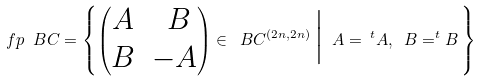Convert formula to latex. <formula><loc_0><loc_0><loc_500><loc_500>\ f p _ { \ } B C = \left \{ \begin{pmatrix} A & \ B \\ B & - A \end{pmatrix} \in \ B C ^ { ( 2 n , 2 n ) } \, \Big | \ A = \, ^ { t } A , \ B = ^ { t } B \, \right \}</formula> 